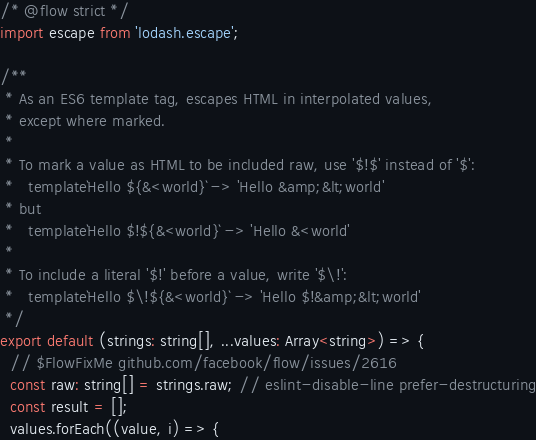Convert code to text. <code><loc_0><loc_0><loc_500><loc_500><_JavaScript_>/* @flow strict */
import escape from 'lodash.escape';

/**
 * As an ES6 template tag, escapes HTML in interpolated values,
 * except where marked.
 *
 * To mark a value as HTML to be included raw, use '$!$' instead of '$':
 *   template`Hello ${&<world}` -> 'Hello &amp;&lt;world'
 * but
 *   template`Hello $!${&<world}` -> 'Hello &<world'
 *
 * To include a literal '$!' before a value, write '$\!':
 *   template`Hello $\!${&<world}` -> 'Hello $!&amp;&lt;world'
 */
export default (strings: string[], ...values: Array<string>) => {
  // $FlowFixMe github.com/facebook/flow/issues/2616
  const raw: string[] = strings.raw; // eslint-disable-line prefer-destructuring
  const result = [];
  values.forEach((value, i) => {</code> 